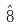<formula> <loc_0><loc_0><loc_500><loc_500>\hat { 8 }</formula> 